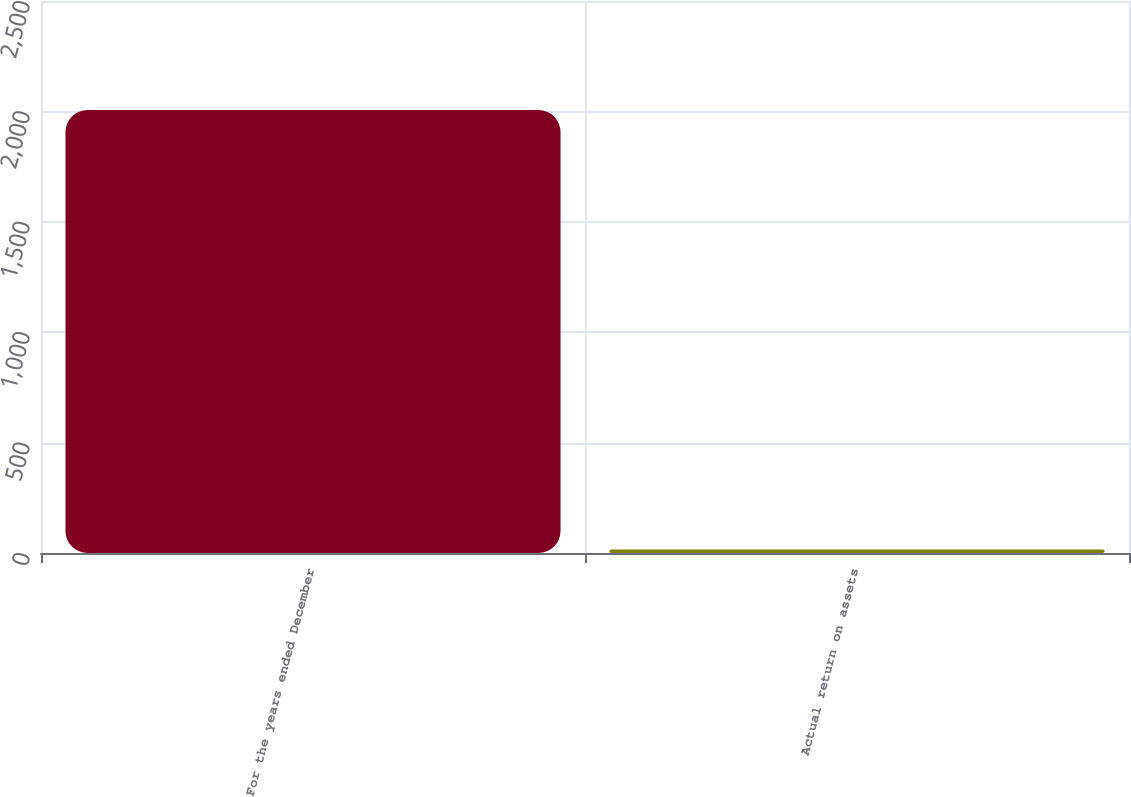Convert chart to OTSL. <chart><loc_0><loc_0><loc_500><loc_500><bar_chart><fcel>For the years ended December<fcel>Actual return on assets<nl><fcel>2006<fcel>15.7<nl></chart> 